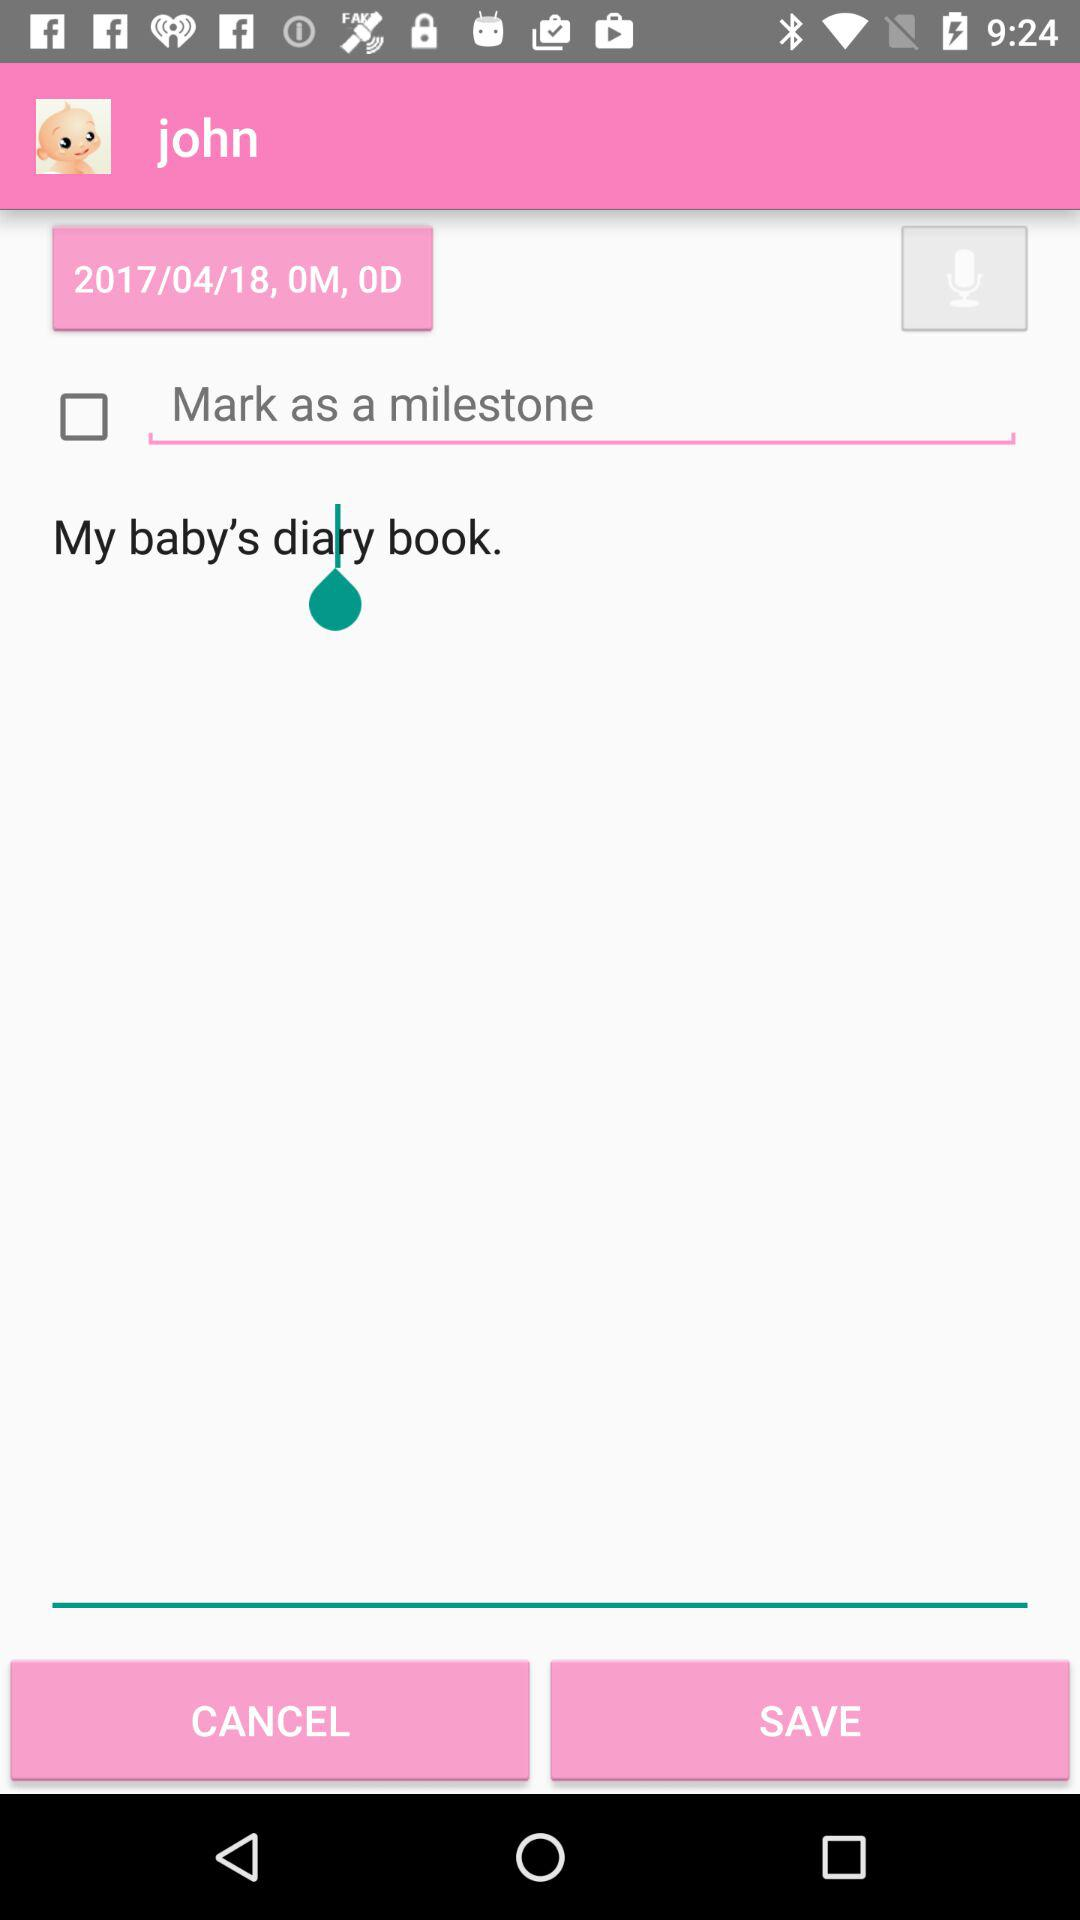What's the mentioned date? The mentioned date is April 18, 2017. 